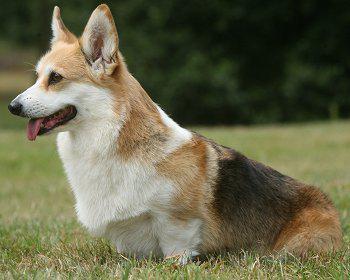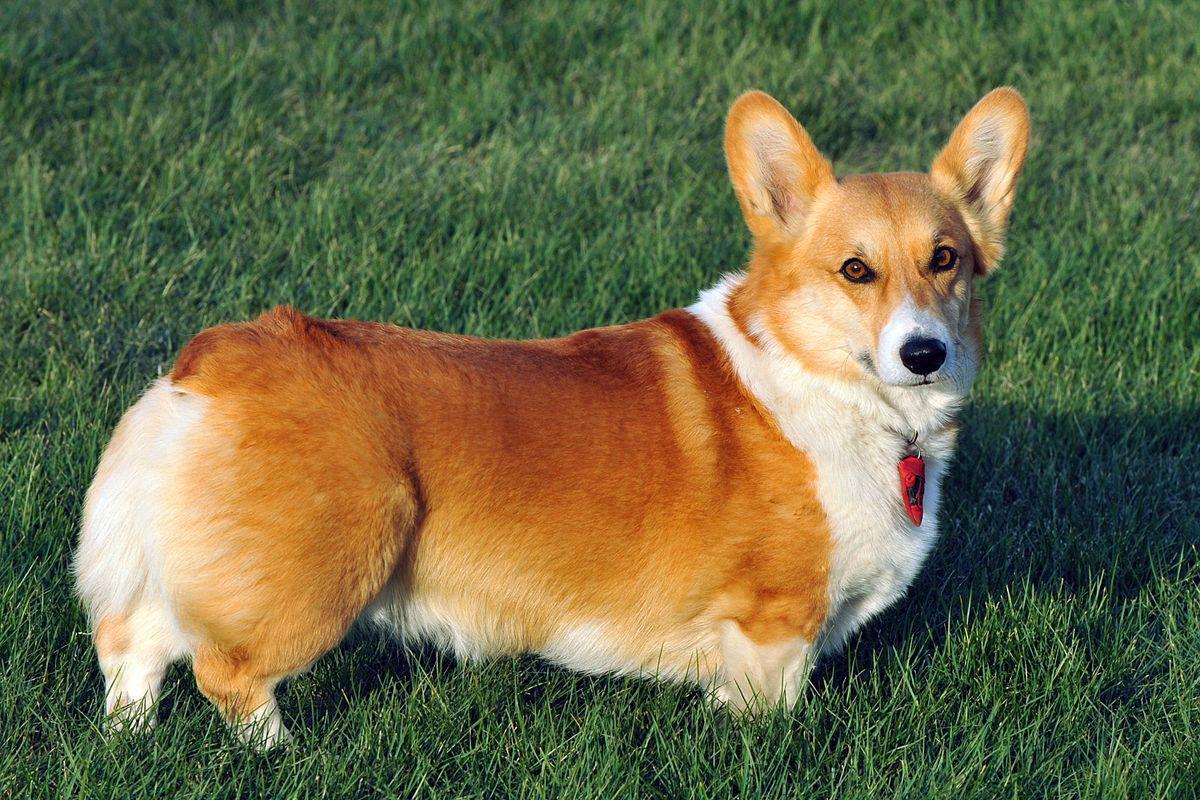The first image is the image on the left, the second image is the image on the right. For the images displayed, is the sentence "In one of the images there is a single corgi sitting on the ground outside." factually correct? Answer yes or no. Yes. The first image is the image on the left, the second image is the image on the right. Assess this claim about the two images: "An image shows a corgi dog moving across the grass, with one front paw raised.". Correct or not? Answer yes or no. No. The first image is the image on the left, the second image is the image on the right. Examine the images to the left and right. Is the description "One dog is standing on the grass." accurate? Answer yes or no. Yes. The first image is the image on the left, the second image is the image on the right. Assess this claim about the two images: "Neither dog is walking or running.". Correct or not? Answer yes or no. Yes. The first image is the image on the left, the second image is the image on the right. Considering the images on both sides, is "Each image shows exactly one corgi dog outdoors on grass." valid? Answer yes or no. Yes. The first image is the image on the left, the second image is the image on the right. Analyze the images presented: Is the assertion "The dog in the image on the left is standing in the grass on all four legs." valid? Answer yes or no. No. 